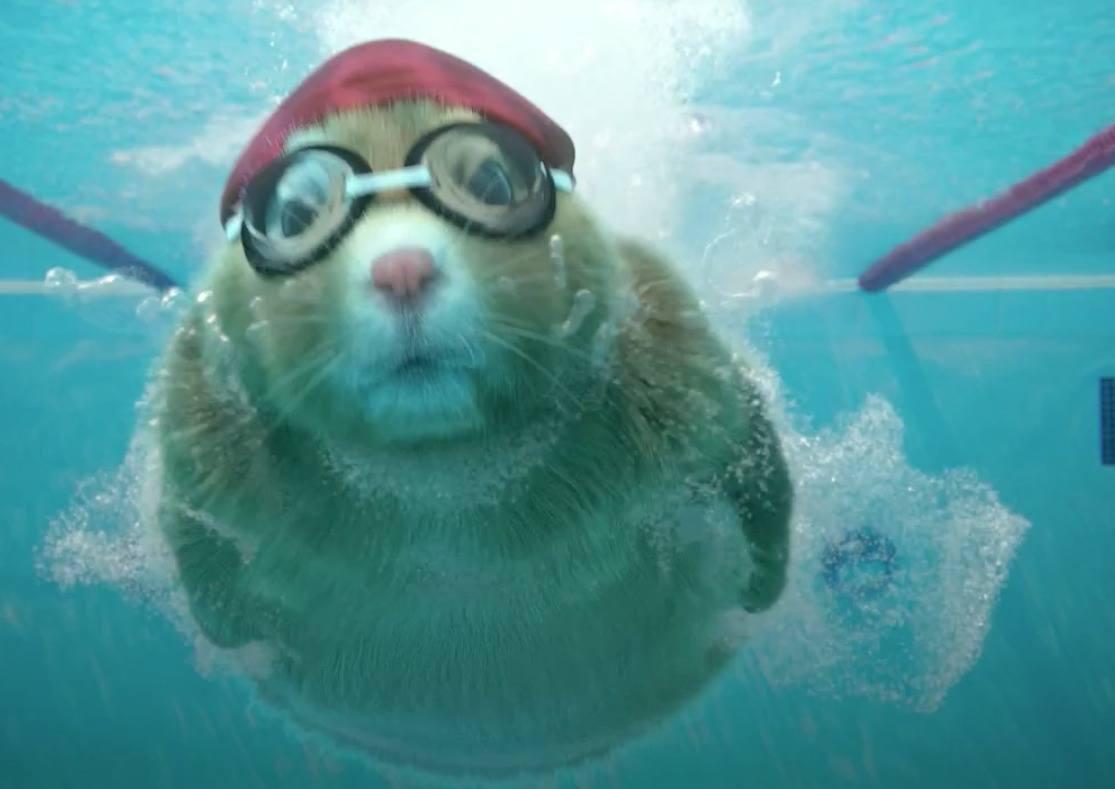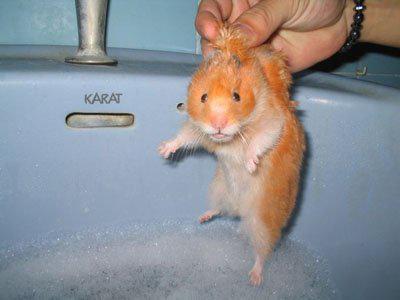The first image is the image on the left, the second image is the image on the right. Examine the images to the left and right. Is the description "in the right side image, there is a human hand holding the animal" accurate? Answer yes or no. Yes. The first image is the image on the left, the second image is the image on the right. Analyze the images presented: Is the assertion "There is a gerbil being held by a single human hand in one of the images." valid? Answer yes or no. Yes. 